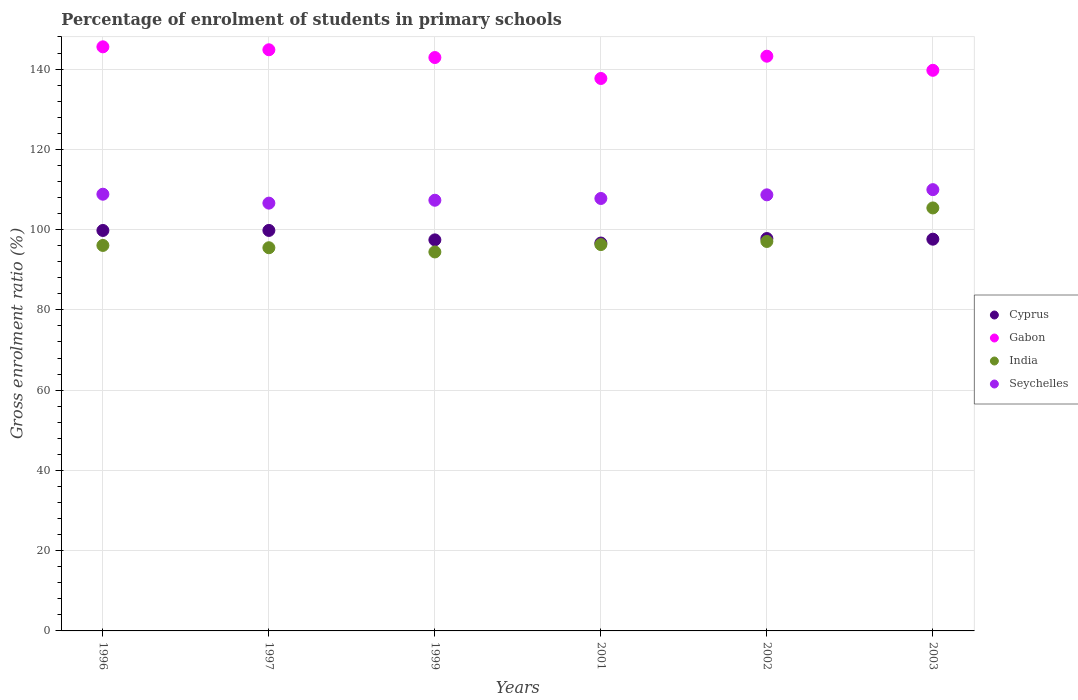What is the percentage of students enrolled in primary schools in India in 2003?
Your answer should be compact. 105.4. Across all years, what is the maximum percentage of students enrolled in primary schools in Seychelles?
Keep it short and to the point. 109.95. Across all years, what is the minimum percentage of students enrolled in primary schools in India?
Keep it short and to the point. 94.43. In which year was the percentage of students enrolled in primary schools in Cyprus maximum?
Keep it short and to the point. 1997. What is the total percentage of students enrolled in primary schools in India in the graph?
Make the answer very short. 584.67. What is the difference between the percentage of students enrolled in primary schools in Seychelles in 1996 and that in 2001?
Keep it short and to the point. 1.06. What is the difference between the percentage of students enrolled in primary schools in Gabon in 1997 and the percentage of students enrolled in primary schools in Cyprus in 1996?
Your answer should be very brief. 45.03. What is the average percentage of students enrolled in primary schools in Cyprus per year?
Provide a short and direct response. 98.17. In the year 2002, what is the difference between the percentage of students enrolled in primary schools in India and percentage of students enrolled in primary schools in Seychelles?
Offer a very short reply. -11.62. What is the ratio of the percentage of students enrolled in primary schools in Seychelles in 1999 to that in 2003?
Provide a succinct answer. 0.98. Is the percentage of students enrolled in primary schools in Seychelles in 1997 less than that in 1999?
Offer a very short reply. Yes. Is the difference between the percentage of students enrolled in primary schools in India in 2001 and 2003 greater than the difference between the percentage of students enrolled in primary schools in Seychelles in 2001 and 2003?
Give a very brief answer. No. What is the difference between the highest and the second highest percentage of students enrolled in primary schools in Seychelles?
Provide a short and direct response. 1.14. What is the difference between the highest and the lowest percentage of students enrolled in primary schools in India?
Your answer should be very brief. 10.97. In how many years, is the percentage of students enrolled in primary schools in Cyprus greater than the average percentage of students enrolled in primary schools in Cyprus taken over all years?
Provide a succinct answer. 2. Is it the case that in every year, the sum of the percentage of students enrolled in primary schools in Seychelles and percentage of students enrolled in primary schools in Gabon  is greater than the sum of percentage of students enrolled in primary schools in Cyprus and percentage of students enrolled in primary schools in India?
Provide a succinct answer. Yes. Is it the case that in every year, the sum of the percentage of students enrolled in primary schools in India and percentage of students enrolled in primary schools in Seychelles  is greater than the percentage of students enrolled in primary schools in Gabon?
Your answer should be compact. Yes. Is the percentage of students enrolled in primary schools in Gabon strictly greater than the percentage of students enrolled in primary schools in Seychelles over the years?
Your answer should be compact. Yes. Is the percentage of students enrolled in primary schools in Cyprus strictly less than the percentage of students enrolled in primary schools in India over the years?
Ensure brevity in your answer.  No. How many years are there in the graph?
Your answer should be compact. 6. What is the difference between two consecutive major ticks on the Y-axis?
Offer a terse response. 20. Are the values on the major ticks of Y-axis written in scientific E-notation?
Your answer should be compact. No. Does the graph contain grids?
Offer a terse response. Yes. Where does the legend appear in the graph?
Your answer should be compact. Center right. How many legend labels are there?
Keep it short and to the point. 4. What is the title of the graph?
Keep it short and to the point. Percentage of enrolment of students in primary schools. What is the Gross enrolment ratio (%) of Cyprus in 1996?
Provide a succinct answer. 99.78. What is the Gross enrolment ratio (%) in Gabon in 1996?
Provide a succinct answer. 145.54. What is the Gross enrolment ratio (%) in India in 1996?
Offer a terse response. 96.05. What is the Gross enrolment ratio (%) in Seychelles in 1996?
Give a very brief answer. 108.82. What is the Gross enrolment ratio (%) in Cyprus in 1997?
Make the answer very short. 99.79. What is the Gross enrolment ratio (%) of Gabon in 1997?
Your answer should be compact. 144.81. What is the Gross enrolment ratio (%) in India in 1997?
Keep it short and to the point. 95.48. What is the Gross enrolment ratio (%) in Seychelles in 1997?
Provide a short and direct response. 106.59. What is the Gross enrolment ratio (%) of Cyprus in 1999?
Give a very brief answer. 97.44. What is the Gross enrolment ratio (%) in Gabon in 1999?
Give a very brief answer. 142.87. What is the Gross enrolment ratio (%) in India in 1999?
Give a very brief answer. 94.43. What is the Gross enrolment ratio (%) in Seychelles in 1999?
Make the answer very short. 107.32. What is the Gross enrolment ratio (%) in Cyprus in 2001?
Your response must be concise. 96.65. What is the Gross enrolment ratio (%) of Gabon in 2001?
Your answer should be compact. 137.66. What is the Gross enrolment ratio (%) in India in 2001?
Make the answer very short. 96.27. What is the Gross enrolment ratio (%) of Seychelles in 2001?
Your answer should be compact. 107.76. What is the Gross enrolment ratio (%) in Cyprus in 2002?
Give a very brief answer. 97.77. What is the Gross enrolment ratio (%) of Gabon in 2002?
Provide a succinct answer. 143.21. What is the Gross enrolment ratio (%) in India in 2002?
Give a very brief answer. 97.04. What is the Gross enrolment ratio (%) in Seychelles in 2002?
Give a very brief answer. 108.66. What is the Gross enrolment ratio (%) in Cyprus in 2003?
Your answer should be very brief. 97.61. What is the Gross enrolment ratio (%) in Gabon in 2003?
Offer a very short reply. 139.69. What is the Gross enrolment ratio (%) in India in 2003?
Give a very brief answer. 105.4. What is the Gross enrolment ratio (%) of Seychelles in 2003?
Give a very brief answer. 109.95. Across all years, what is the maximum Gross enrolment ratio (%) in Cyprus?
Provide a succinct answer. 99.79. Across all years, what is the maximum Gross enrolment ratio (%) in Gabon?
Provide a succinct answer. 145.54. Across all years, what is the maximum Gross enrolment ratio (%) of India?
Offer a very short reply. 105.4. Across all years, what is the maximum Gross enrolment ratio (%) of Seychelles?
Ensure brevity in your answer.  109.95. Across all years, what is the minimum Gross enrolment ratio (%) in Cyprus?
Ensure brevity in your answer.  96.65. Across all years, what is the minimum Gross enrolment ratio (%) of Gabon?
Offer a terse response. 137.66. Across all years, what is the minimum Gross enrolment ratio (%) in India?
Give a very brief answer. 94.43. Across all years, what is the minimum Gross enrolment ratio (%) in Seychelles?
Offer a very short reply. 106.59. What is the total Gross enrolment ratio (%) in Cyprus in the graph?
Give a very brief answer. 589.05. What is the total Gross enrolment ratio (%) of Gabon in the graph?
Give a very brief answer. 853.78. What is the total Gross enrolment ratio (%) in India in the graph?
Offer a terse response. 584.67. What is the total Gross enrolment ratio (%) of Seychelles in the graph?
Make the answer very short. 649.1. What is the difference between the Gross enrolment ratio (%) in Cyprus in 1996 and that in 1997?
Keep it short and to the point. -0.01. What is the difference between the Gross enrolment ratio (%) of Gabon in 1996 and that in 1997?
Provide a short and direct response. 0.73. What is the difference between the Gross enrolment ratio (%) in India in 1996 and that in 1997?
Your answer should be very brief. 0.57. What is the difference between the Gross enrolment ratio (%) in Seychelles in 1996 and that in 1997?
Your answer should be compact. 2.22. What is the difference between the Gross enrolment ratio (%) of Cyprus in 1996 and that in 1999?
Your answer should be compact. 2.35. What is the difference between the Gross enrolment ratio (%) of Gabon in 1996 and that in 1999?
Your answer should be very brief. 2.67. What is the difference between the Gross enrolment ratio (%) in India in 1996 and that in 1999?
Provide a succinct answer. 1.62. What is the difference between the Gross enrolment ratio (%) in Seychelles in 1996 and that in 1999?
Provide a short and direct response. 1.5. What is the difference between the Gross enrolment ratio (%) of Cyprus in 1996 and that in 2001?
Offer a terse response. 3.13. What is the difference between the Gross enrolment ratio (%) of Gabon in 1996 and that in 2001?
Your answer should be very brief. 7.88. What is the difference between the Gross enrolment ratio (%) of India in 1996 and that in 2001?
Provide a short and direct response. -0.21. What is the difference between the Gross enrolment ratio (%) in Seychelles in 1996 and that in 2001?
Provide a short and direct response. 1.06. What is the difference between the Gross enrolment ratio (%) in Cyprus in 1996 and that in 2002?
Your response must be concise. 2.01. What is the difference between the Gross enrolment ratio (%) of Gabon in 1996 and that in 2002?
Your response must be concise. 2.34. What is the difference between the Gross enrolment ratio (%) of India in 1996 and that in 2002?
Keep it short and to the point. -0.99. What is the difference between the Gross enrolment ratio (%) of Seychelles in 1996 and that in 2002?
Offer a very short reply. 0.16. What is the difference between the Gross enrolment ratio (%) in Cyprus in 1996 and that in 2003?
Give a very brief answer. 2.17. What is the difference between the Gross enrolment ratio (%) of Gabon in 1996 and that in 2003?
Make the answer very short. 5.85. What is the difference between the Gross enrolment ratio (%) of India in 1996 and that in 2003?
Provide a short and direct response. -9.34. What is the difference between the Gross enrolment ratio (%) of Seychelles in 1996 and that in 2003?
Your response must be concise. -1.14. What is the difference between the Gross enrolment ratio (%) in Cyprus in 1997 and that in 1999?
Your answer should be very brief. 2.35. What is the difference between the Gross enrolment ratio (%) in Gabon in 1997 and that in 1999?
Offer a terse response. 1.93. What is the difference between the Gross enrolment ratio (%) of India in 1997 and that in 1999?
Give a very brief answer. 1.05. What is the difference between the Gross enrolment ratio (%) of Seychelles in 1997 and that in 1999?
Keep it short and to the point. -0.72. What is the difference between the Gross enrolment ratio (%) of Cyprus in 1997 and that in 2001?
Keep it short and to the point. 3.14. What is the difference between the Gross enrolment ratio (%) in Gabon in 1997 and that in 2001?
Your response must be concise. 7.15. What is the difference between the Gross enrolment ratio (%) of India in 1997 and that in 2001?
Provide a short and direct response. -0.79. What is the difference between the Gross enrolment ratio (%) in Seychelles in 1997 and that in 2001?
Provide a short and direct response. -1.16. What is the difference between the Gross enrolment ratio (%) of Cyprus in 1997 and that in 2002?
Your answer should be very brief. 2.02. What is the difference between the Gross enrolment ratio (%) of Gabon in 1997 and that in 2002?
Your answer should be compact. 1.6. What is the difference between the Gross enrolment ratio (%) of India in 1997 and that in 2002?
Make the answer very short. -1.56. What is the difference between the Gross enrolment ratio (%) in Seychelles in 1997 and that in 2002?
Your answer should be compact. -2.07. What is the difference between the Gross enrolment ratio (%) of Cyprus in 1997 and that in 2003?
Your answer should be compact. 2.18. What is the difference between the Gross enrolment ratio (%) of Gabon in 1997 and that in 2003?
Your response must be concise. 5.12. What is the difference between the Gross enrolment ratio (%) of India in 1997 and that in 2003?
Provide a short and direct response. -9.92. What is the difference between the Gross enrolment ratio (%) in Seychelles in 1997 and that in 2003?
Make the answer very short. -3.36. What is the difference between the Gross enrolment ratio (%) in Cyprus in 1999 and that in 2001?
Your answer should be compact. 0.79. What is the difference between the Gross enrolment ratio (%) of Gabon in 1999 and that in 2001?
Your answer should be compact. 5.22. What is the difference between the Gross enrolment ratio (%) in India in 1999 and that in 2001?
Provide a succinct answer. -1.84. What is the difference between the Gross enrolment ratio (%) of Seychelles in 1999 and that in 2001?
Provide a short and direct response. -0.44. What is the difference between the Gross enrolment ratio (%) of Cyprus in 1999 and that in 2002?
Your response must be concise. -0.34. What is the difference between the Gross enrolment ratio (%) in Gabon in 1999 and that in 2002?
Give a very brief answer. -0.33. What is the difference between the Gross enrolment ratio (%) of India in 1999 and that in 2002?
Provide a succinct answer. -2.61. What is the difference between the Gross enrolment ratio (%) in Seychelles in 1999 and that in 2002?
Keep it short and to the point. -1.34. What is the difference between the Gross enrolment ratio (%) of Cyprus in 1999 and that in 2003?
Give a very brief answer. -0.17. What is the difference between the Gross enrolment ratio (%) of Gabon in 1999 and that in 2003?
Your answer should be very brief. 3.18. What is the difference between the Gross enrolment ratio (%) of India in 1999 and that in 2003?
Provide a succinct answer. -10.97. What is the difference between the Gross enrolment ratio (%) of Seychelles in 1999 and that in 2003?
Your response must be concise. -2.64. What is the difference between the Gross enrolment ratio (%) of Cyprus in 2001 and that in 2002?
Your response must be concise. -1.12. What is the difference between the Gross enrolment ratio (%) in Gabon in 2001 and that in 2002?
Your answer should be compact. -5.55. What is the difference between the Gross enrolment ratio (%) of India in 2001 and that in 2002?
Make the answer very short. -0.78. What is the difference between the Gross enrolment ratio (%) of Seychelles in 2001 and that in 2002?
Provide a succinct answer. -0.91. What is the difference between the Gross enrolment ratio (%) in Cyprus in 2001 and that in 2003?
Your answer should be compact. -0.96. What is the difference between the Gross enrolment ratio (%) of Gabon in 2001 and that in 2003?
Give a very brief answer. -2.04. What is the difference between the Gross enrolment ratio (%) in India in 2001 and that in 2003?
Ensure brevity in your answer.  -9.13. What is the difference between the Gross enrolment ratio (%) in Seychelles in 2001 and that in 2003?
Your response must be concise. -2.2. What is the difference between the Gross enrolment ratio (%) of Cyprus in 2002 and that in 2003?
Make the answer very short. 0.16. What is the difference between the Gross enrolment ratio (%) in Gabon in 2002 and that in 2003?
Your response must be concise. 3.51. What is the difference between the Gross enrolment ratio (%) in India in 2002 and that in 2003?
Make the answer very short. -8.35. What is the difference between the Gross enrolment ratio (%) in Seychelles in 2002 and that in 2003?
Your response must be concise. -1.29. What is the difference between the Gross enrolment ratio (%) of Cyprus in 1996 and the Gross enrolment ratio (%) of Gabon in 1997?
Ensure brevity in your answer.  -45.03. What is the difference between the Gross enrolment ratio (%) of Cyprus in 1996 and the Gross enrolment ratio (%) of India in 1997?
Provide a short and direct response. 4.3. What is the difference between the Gross enrolment ratio (%) of Cyprus in 1996 and the Gross enrolment ratio (%) of Seychelles in 1997?
Ensure brevity in your answer.  -6.81. What is the difference between the Gross enrolment ratio (%) of Gabon in 1996 and the Gross enrolment ratio (%) of India in 1997?
Ensure brevity in your answer.  50.06. What is the difference between the Gross enrolment ratio (%) of Gabon in 1996 and the Gross enrolment ratio (%) of Seychelles in 1997?
Provide a succinct answer. 38.95. What is the difference between the Gross enrolment ratio (%) of India in 1996 and the Gross enrolment ratio (%) of Seychelles in 1997?
Your answer should be very brief. -10.54. What is the difference between the Gross enrolment ratio (%) in Cyprus in 1996 and the Gross enrolment ratio (%) in Gabon in 1999?
Ensure brevity in your answer.  -43.09. What is the difference between the Gross enrolment ratio (%) of Cyprus in 1996 and the Gross enrolment ratio (%) of India in 1999?
Ensure brevity in your answer.  5.35. What is the difference between the Gross enrolment ratio (%) in Cyprus in 1996 and the Gross enrolment ratio (%) in Seychelles in 1999?
Offer a very short reply. -7.53. What is the difference between the Gross enrolment ratio (%) of Gabon in 1996 and the Gross enrolment ratio (%) of India in 1999?
Provide a short and direct response. 51.11. What is the difference between the Gross enrolment ratio (%) in Gabon in 1996 and the Gross enrolment ratio (%) in Seychelles in 1999?
Ensure brevity in your answer.  38.23. What is the difference between the Gross enrolment ratio (%) of India in 1996 and the Gross enrolment ratio (%) of Seychelles in 1999?
Provide a succinct answer. -11.26. What is the difference between the Gross enrolment ratio (%) in Cyprus in 1996 and the Gross enrolment ratio (%) in Gabon in 2001?
Make the answer very short. -37.87. What is the difference between the Gross enrolment ratio (%) of Cyprus in 1996 and the Gross enrolment ratio (%) of India in 2001?
Provide a succinct answer. 3.52. What is the difference between the Gross enrolment ratio (%) in Cyprus in 1996 and the Gross enrolment ratio (%) in Seychelles in 2001?
Provide a succinct answer. -7.97. What is the difference between the Gross enrolment ratio (%) in Gabon in 1996 and the Gross enrolment ratio (%) in India in 2001?
Provide a succinct answer. 49.27. What is the difference between the Gross enrolment ratio (%) of Gabon in 1996 and the Gross enrolment ratio (%) of Seychelles in 2001?
Your answer should be very brief. 37.79. What is the difference between the Gross enrolment ratio (%) in India in 1996 and the Gross enrolment ratio (%) in Seychelles in 2001?
Offer a terse response. -11.7. What is the difference between the Gross enrolment ratio (%) in Cyprus in 1996 and the Gross enrolment ratio (%) in Gabon in 2002?
Offer a very short reply. -43.42. What is the difference between the Gross enrolment ratio (%) of Cyprus in 1996 and the Gross enrolment ratio (%) of India in 2002?
Offer a very short reply. 2.74. What is the difference between the Gross enrolment ratio (%) of Cyprus in 1996 and the Gross enrolment ratio (%) of Seychelles in 2002?
Offer a very short reply. -8.88. What is the difference between the Gross enrolment ratio (%) in Gabon in 1996 and the Gross enrolment ratio (%) in India in 2002?
Your answer should be compact. 48.5. What is the difference between the Gross enrolment ratio (%) in Gabon in 1996 and the Gross enrolment ratio (%) in Seychelles in 2002?
Keep it short and to the point. 36.88. What is the difference between the Gross enrolment ratio (%) of India in 1996 and the Gross enrolment ratio (%) of Seychelles in 2002?
Your answer should be very brief. -12.61. What is the difference between the Gross enrolment ratio (%) in Cyprus in 1996 and the Gross enrolment ratio (%) in Gabon in 2003?
Give a very brief answer. -39.91. What is the difference between the Gross enrolment ratio (%) in Cyprus in 1996 and the Gross enrolment ratio (%) in India in 2003?
Offer a terse response. -5.61. What is the difference between the Gross enrolment ratio (%) of Cyprus in 1996 and the Gross enrolment ratio (%) of Seychelles in 2003?
Your response must be concise. -10.17. What is the difference between the Gross enrolment ratio (%) of Gabon in 1996 and the Gross enrolment ratio (%) of India in 2003?
Your answer should be very brief. 40.14. What is the difference between the Gross enrolment ratio (%) in Gabon in 1996 and the Gross enrolment ratio (%) in Seychelles in 2003?
Your answer should be very brief. 35.59. What is the difference between the Gross enrolment ratio (%) in India in 1996 and the Gross enrolment ratio (%) in Seychelles in 2003?
Offer a terse response. -13.9. What is the difference between the Gross enrolment ratio (%) in Cyprus in 1997 and the Gross enrolment ratio (%) in Gabon in 1999?
Offer a very short reply. -43.08. What is the difference between the Gross enrolment ratio (%) in Cyprus in 1997 and the Gross enrolment ratio (%) in India in 1999?
Provide a succinct answer. 5.36. What is the difference between the Gross enrolment ratio (%) of Cyprus in 1997 and the Gross enrolment ratio (%) of Seychelles in 1999?
Provide a succinct answer. -7.52. What is the difference between the Gross enrolment ratio (%) of Gabon in 1997 and the Gross enrolment ratio (%) of India in 1999?
Offer a very short reply. 50.38. What is the difference between the Gross enrolment ratio (%) of Gabon in 1997 and the Gross enrolment ratio (%) of Seychelles in 1999?
Keep it short and to the point. 37.49. What is the difference between the Gross enrolment ratio (%) of India in 1997 and the Gross enrolment ratio (%) of Seychelles in 1999?
Offer a very short reply. -11.84. What is the difference between the Gross enrolment ratio (%) of Cyprus in 1997 and the Gross enrolment ratio (%) of Gabon in 2001?
Offer a terse response. -37.86. What is the difference between the Gross enrolment ratio (%) in Cyprus in 1997 and the Gross enrolment ratio (%) in India in 2001?
Make the answer very short. 3.53. What is the difference between the Gross enrolment ratio (%) of Cyprus in 1997 and the Gross enrolment ratio (%) of Seychelles in 2001?
Provide a succinct answer. -7.96. What is the difference between the Gross enrolment ratio (%) in Gabon in 1997 and the Gross enrolment ratio (%) in India in 2001?
Provide a succinct answer. 48.54. What is the difference between the Gross enrolment ratio (%) in Gabon in 1997 and the Gross enrolment ratio (%) in Seychelles in 2001?
Ensure brevity in your answer.  37.05. What is the difference between the Gross enrolment ratio (%) in India in 1997 and the Gross enrolment ratio (%) in Seychelles in 2001?
Offer a terse response. -12.28. What is the difference between the Gross enrolment ratio (%) of Cyprus in 1997 and the Gross enrolment ratio (%) of Gabon in 2002?
Keep it short and to the point. -43.41. What is the difference between the Gross enrolment ratio (%) in Cyprus in 1997 and the Gross enrolment ratio (%) in India in 2002?
Ensure brevity in your answer.  2.75. What is the difference between the Gross enrolment ratio (%) in Cyprus in 1997 and the Gross enrolment ratio (%) in Seychelles in 2002?
Provide a short and direct response. -8.87. What is the difference between the Gross enrolment ratio (%) in Gabon in 1997 and the Gross enrolment ratio (%) in India in 2002?
Provide a succinct answer. 47.77. What is the difference between the Gross enrolment ratio (%) in Gabon in 1997 and the Gross enrolment ratio (%) in Seychelles in 2002?
Your response must be concise. 36.15. What is the difference between the Gross enrolment ratio (%) in India in 1997 and the Gross enrolment ratio (%) in Seychelles in 2002?
Make the answer very short. -13.18. What is the difference between the Gross enrolment ratio (%) in Cyprus in 1997 and the Gross enrolment ratio (%) in Gabon in 2003?
Provide a succinct answer. -39.9. What is the difference between the Gross enrolment ratio (%) in Cyprus in 1997 and the Gross enrolment ratio (%) in India in 2003?
Make the answer very short. -5.6. What is the difference between the Gross enrolment ratio (%) of Cyprus in 1997 and the Gross enrolment ratio (%) of Seychelles in 2003?
Provide a short and direct response. -10.16. What is the difference between the Gross enrolment ratio (%) of Gabon in 1997 and the Gross enrolment ratio (%) of India in 2003?
Your answer should be very brief. 39.41. What is the difference between the Gross enrolment ratio (%) in Gabon in 1997 and the Gross enrolment ratio (%) in Seychelles in 2003?
Your answer should be very brief. 34.85. What is the difference between the Gross enrolment ratio (%) of India in 1997 and the Gross enrolment ratio (%) of Seychelles in 2003?
Offer a very short reply. -14.48. What is the difference between the Gross enrolment ratio (%) in Cyprus in 1999 and the Gross enrolment ratio (%) in Gabon in 2001?
Give a very brief answer. -40.22. What is the difference between the Gross enrolment ratio (%) of Cyprus in 1999 and the Gross enrolment ratio (%) of India in 2001?
Give a very brief answer. 1.17. What is the difference between the Gross enrolment ratio (%) in Cyprus in 1999 and the Gross enrolment ratio (%) in Seychelles in 2001?
Give a very brief answer. -10.32. What is the difference between the Gross enrolment ratio (%) in Gabon in 1999 and the Gross enrolment ratio (%) in India in 2001?
Offer a very short reply. 46.61. What is the difference between the Gross enrolment ratio (%) in Gabon in 1999 and the Gross enrolment ratio (%) in Seychelles in 2001?
Provide a short and direct response. 35.12. What is the difference between the Gross enrolment ratio (%) of India in 1999 and the Gross enrolment ratio (%) of Seychelles in 2001?
Ensure brevity in your answer.  -13.32. What is the difference between the Gross enrolment ratio (%) in Cyprus in 1999 and the Gross enrolment ratio (%) in Gabon in 2002?
Keep it short and to the point. -45.77. What is the difference between the Gross enrolment ratio (%) of Cyprus in 1999 and the Gross enrolment ratio (%) of India in 2002?
Your answer should be compact. 0.4. What is the difference between the Gross enrolment ratio (%) in Cyprus in 1999 and the Gross enrolment ratio (%) in Seychelles in 2002?
Offer a terse response. -11.22. What is the difference between the Gross enrolment ratio (%) of Gabon in 1999 and the Gross enrolment ratio (%) of India in 2002?
Give a very brief answer. 45.83. What is the difference between the Gross enrolment ratio (%) in Gabon in 1999 and the Gross enrolment ratio (%) in Seychelles in 2002?
Provide a short and direct response. 34.21. What is the difference between the Gross enrolment ratio (%) in India in 1999 and the Gross enrolment ratio (%) in Seychelles in 2002?
Your answer should be compact. -14.23. What is the difference between the Gross enrolment ratio (%) of Cyprus in 1999 and the Gross enrolment ratio (%) of Gabon in 2003?
Your answer should be compact. -42.25. What is the difference between the Gross enrolment ratio (%) of Cyprus in 1999 and the Gross enrolment ratio (%) of India in 2003?
Give a very brief answer. -7.96. What is the difference between the Gross enrolment ratio (%) of Cyprus in 1999 and the Gross enrolment ratio (%) of Seychelles in 2003?
Your answer should be compact. -12.52. What is the difference between the Gross enrolment ratio (%) in Gabon in 1999 and the Gross enrolment ratio (%) in India in 2003?
Offer a very short reply. 37.48. What is the difference between the Gross enrolment ratio (%) of Gabon in 1999 and the Gross enrolment ratio (%) of Seychelles in 2003?
Give a very brief answer. 32.92. What is the difference between the Gross enrolment ratio (%) in India in 1999 and the Gross enrolment ratio (%) in Seychelles in 2003?
Your answer should be very brief. -15.52. What is the difference between the Gross enrolment ratio (%) in Cyprus in 2001 and the Gross enrolment ratio (%) in Gabon in 2002?
Make the answer very short. -46.56. What is the difference between the Gross enrolment ratio (%) of Cyprus in 2001 and the Gross enrolment ratio (%) of India in 2002?
Give a very brief answer. -0.39. What is the difference between the Gross enrolment ratio (%) of Cyprus in 2001 and the Gross enrolment ratio (%) of Seychelles in 2002?
Provide a succinct answer. -12.01. What is the difference between the Gross enrolment ratio (%) in Gabon in 2001 and the Gross enrolment ratio (%) in India in 2002?
Your answer should be compact. 40.61. What is the difference between the Gross enrolment ratio (%) in Gabon in 2001 and the Gross enrolment ratio (%) in Seychelles in 2002?
Your response must be concise. 29. What is the difference between the Gross enrolment ratio (%) in India in 2001 and the Gross enrolment ratio (%) in Seychelles in 2002?
Offer a terse response. -12.39. What is the difference between the Gross enrolment ratio (%) of Cyprus in 2001 and the Gross enrolment ratio (%) of Gabon in 2003?
Offer a very short reply. -43.04. What is the difference between the Gross enrolment ratio (%) of Cyprus in 2001 and the Gross enrolment ratio (%) of India in 2003?
Make the answer very short. -8.75. What is the difference between the Gross enrolment ratio (%) in Cyprus in 2001 and the Gross enrolment ratio (%) in Seychelles in 2003?
Offer a very short reply. -13.31. What is the difference between the Gross enrolment ratio (%) in Gabon in 2001 and the Gross enrolment ratio (%) in India in 2003?
Provide a succinct answer. 32.26. What is the difference between the Gross enrolment ratio (%) of Gabon in 2001 and the Gross enrolment ratio (%) of Seychelles in 2003?
Ensure brevity in your answer.  27.7. What is the difference between the Gross enrolment ratio (%) in India in 2001 and the Gross enrolment ratio (%) in Seychelles in 2003?
Your answer should be very brief. -13.69. What is the difference between the Gross enrolment ratio (%) in Cyprus in 2002 and the Gross enrolment ratio (%) in Gabon in 2003?
Your answer should be compact. -41.92. What is the difference between the Gross enrolment ratio (%) in Cyprus in 2002 and the Gross enrolment ratio (%) in India in 2003?
Ensure brevity in your answer.  -7.62. What is the difference between the Gross enrolment ratio (%) of Cyprus in 2002 and the Gross enrolment ratio (%) of Seychelles in 2003?
Offer a very short reply. -12.18. What is the difference between the Gross enrolment ratio (%) in Gabon in 2002 and the Gross enrolment ratio (%) in India in 2003?
Your response must be concise. 37.81. What is the difference between the Gross enrolment ratio (%) of Gabon in 2002 and the Gross enrolment ratio (%) of Seychelles in 2003?
Your response must be concise. 33.25. What is the difference between the Gross enrolment ratio (%) of India in 2002 and the Gross enrolment ratio (%) of Seychelles in 2003?
Your response must be concise. -12.91. What is the average Gross enrolment ratio (%) of Cyprus per year?
Provide a succinct answer. 98.17. What is the average Gross enrolment ratio (%) in Gabon per year?
Provide a succinct answer. 142.3. What is the average Gross enrolment ratio (%) of India per year?
Give a very brief answer. 97.44. What is the average Gross enrolment ratio (%) of Seychelles per year?
Make the answer very short. 108.18. In the year 1996, what is the difference between the Gross enrolment ratio (%) in Cyprus and Gross enrolment ratio (%) in Gabon?
Provide a short and direct response. -45.76. In the year 1996, what is the difference between the Gross enrolment ratio (%) in Cyprus and Gross enrolment ratio (%) in India?
Provide a succinct answer. 3.73. In the year 1996, what is the difference between the Gross enrolment ratio (%) of Cyprus and Gross enrolment ratio (%) of Seychelles?
Keep it short and to the point. -9.03. In the year 1996, what is the difference between the Gross enrolment ratio (%) in Gabon and Gross enrolment ratio (%) in India?
Your response must be concise. 49.49. In the year 1996, what is the difference between the Gross enrolment ratio (%) in Gabon and Gross enrolment ratio (%) in Seychelles?
Give a very brief answer. 36.72. In the year 1996, what is the difference between the Gross enrolment ratio (%) of India and Gross enrolment ratio (%) of Seychelles?
Ensure brevity in your answer.  -12.76. In the year 1997, what is the difference between the Gross enrolment ratio (%) of Cyprus and Gross enrolment ratio (%) of Gabon?
Offer a terse response. -45.02. In the year 1997, what is the difference between the Gross enrolment ratio (%) of Cyprus and Gross enrolment ratio (%) of India?
Your answer should be compact. 4.31. In the year 1997, what is the difference between the Gross enrolment ratio (%) of Cyprus and Gross enrolment ratio (%) of Seychelles?
Ensure brevity in your answer.  -6.8. In the year 1997, what is the difference between the Gross enrolment ratio (%) of Gabon and Gross enrolment ratio (%) of India?
Keep it short and to the point. 49.33. In the year 1997, what is the difference between the Gross enrolment ratio (%) of Gabon and Gross enrolment ratio (%) of Seychelles?
Your answer should be compact. 38.22. In the year 1997, what is the difference between the Gross enrolment ratio (%) in India and Gross enrolment ratio (%) in Seychelles?
Offer a terse response. -11.12. In the year 1999, what is the difference between the Gross enrolment ratio (%) in Cyprus and Gross enrolment ratio (%) in Gabon?
Your answer should be very brief. -45.44. In the year 1999, what is the difference between the Gross enrolment ratio (%) in Cyprus and Gross enrolment ratio (%) in India?
Keep it short and to the point. 3.01. In the year 1999, what is the difference between the Gross enrolment ratio (%) of Cyprus and Gross enrolment ratio (%) of Seychelles?
Provide a succinct answer. -9.88. In the year 1999, what is the difference between the Gross enrolment ratio (%) of Gabon and Gross enrolment ratio (%) of India?
Give a very brief answer. 48.44. In the year 1999, what is the difference between the Gross enrolment ratio (%) in Gabon and Gross enrolment ratio (%) in Seychelles?
Offer a very short reply. 35.56. In the year 1999, what is the difference between the Gross enrolment ratio (%) in India and Gross enrolment ratio (%) in Seychelles?
Offer a very short reply. -12.89. In the year 2001, what is the difference between the Gross enrolment ratio (%) of Cyprus and Gross enrolment ratio (%) of Gabon?
Provide a short and direct response. -41.01. In the year 2001, what is the difference between the Gross enrolment ratio (%) in Cyprus and Gross enrolment ratio (%) in India?
Your answer should be compact. 0.38. In the year 2001, what is the difference between the Gross enrolment ratio (%) of Cyprus and Gross enrolment ratio (%) of Seychelles?
Give a very brief answer. -11.11. In the year 2001, what is the difference between the Gross enrolment ratio (%) in Gabon and Gross enrolment ratio (%) in India?
Keep it short and to the point. 41.39. In the year 2001, what is the difference between the Gross enrolment ratio (%) of Gabon and Gross enrolment ratio (%) of Seychelles?
Offer a very short reply. 29.9. In the year 2001, what is the difference between the Gross enrolment ratio (%) in India and Gross enrolment ratio (%) in Seychelles?
Your answer should be very brief. -11.49. In the year 2002, what is the difference between the Gross enrolment ratio (%) of Cyprus and Gross enrolment ratio (%) of Gabon?
Your answer should be compact. -45.43. In the year 2002, what is the difference between the Gross enrolment ratio (%) of Cyprus and Gross enrolment ratio (%) of India?
Keep it short and to the point. 0.73. In the year 2002, what is the difference between the Gross enrolment ratio (%) in Cyprus and Gross enrolment ratio (%) in Seychelles?
Keep it short and to the point. -10.89. In the year 2002, what is the difference between the Gross enrolment ratio (%) in Gabon and Gross enrolment ratio (%) in India?
Ensure brevity in your answer.  46.16. In the year 2002, what is the difference between the Gross enrolment ratio (%) of Gabon and Gross enrolment ratio (%) of Seychelles?
Ensure brevity in your answer.  34.54. In the year 2002, what is the difference between the Gross enrolment ratio (%) of India and Gross enrolment ratio (%) of Seychelles?
Your answer should be very brief. -11.62. In the year 2003, what is the difference between the Gross enrolment ratio (%) in Cyprus and Gross enrolment ratio (%) in Gabon?
Keep it short and to the point. -42.08. In the year 2003, what is the difference between the Gross enrolment ratio (%) of Cyprus and Gross enrolment ratio (%) of India?
Keep it short and to the point. -7.79. In the year 2003, what is the difference between the Gross enrolment ratio (%) in Cyprus and Gross enrolment ratio (%) in Seychelles?
Your answer should be very brief. -12.34. In the year 2003, what is the difference between the Gross enrolment ratio (%) of Gabon and Gross enrolment ratio (%) of India?
Make the answer very short. 34.3. In the year 2003, what is the difference between the Gross enrolment ratio (%) in Gabon and Gross enrolment ratio (%) in Seychelles?
Provide a short and direct response. 29.74. In the year 2003, what is the difference between the Gross enrolment ratio (%) in India and Gross enrolment ratio (%) in Seychelles?
Your answer should be compact. -4.56. What is the ratio of the Gross enrolment ratio (%) in Cyprus in 1996 to that in 1997?
Your answer should be very brief. 1. What is the ratio of the Gross enrolment ratio (%) in India in 1996 to that in 1997?
Provide a succinct answer. 1.01. What is the ratio of the Gross enrolment ratio (%) of Seychelles in 1996 to that in 1997?
Make the answer very short. 1.02. What is the ratio of the Gross enrolment ratio (%) in Cyprus in 1996 to that in 1999?
Keep it short and to the point. 1.02. What is the ratio of the Gross enrolment ratio (%) of Gabon in 1996 to that in 1999?
Offer a terse response. 1.02. What is the ratio of the Gross enrolment ratio (%) in India in 1996 to that in 1999?
Provide a short and direct response. 1.02. What is the ratio of the Gross enrolment ratio (%) in Cyprus in 1996 to that in 2001?
Provide a succinct answer. 1.03. What is the ratio of the Gross enrolment ratio (%) of Gabon in 1996 to that in 2001?
Give a very brief answer. 1.06. What is the ratio of the Gross enrolment ratio (%) in India in 1996 to that in 2001?
Give a very brief answer. 1. What is the ratio of the Gross enrolment ratio (%) of Seychelles in 1996 to that in 2001?
Offer a terse response. 1.01. What is the ratio of the Gross enrolment ratio (%) in Cyprus in 1996 to that in 2002?
Your answer should be compact. 1.02. What is the ratio of the Gross enrolment ratio (%) of Gabon in 1996 to that in 2002?
Keep it short and to the point. 1.02. What is the ratio of the Gross enrolment ratio (%) of Cyprus in 1996 to that in 2003?
Offer a very short reply. 1.02. What is the ratio of the Gross enrolment ratio (%) of Gabon in 1996 to that in 2003?
Your answer should be compact. 1.04. What is the ratio of the Gross enrolment ratio (%) in India in 1996 to that in 2003?
Provide a short and direct response. 0.91. What is the ratio of the Gross enrolment ratio (%) in Cyprus in 1997 to that in 1999?
Your answer should be compact. 1.02. What is the ratio of the Gross enrolment ratio (%) of Gabon in 1997 to that in 1999?
Your answer should be very brief. 1.01. What is the ratio of the Gross enrolment ratio (%) of India in 1997 to that in 1999?
Your response must be concise. 1.01. What is the ratio of the Gross enrolment ratio (%) in Seychelles in 1997 to that in 1999?
Your response must be concise. 0.99. What is the ratio of the Gross enrolment ratio (%) of Cyprus in 1997 to that in 2001?
Offer a terse response. 1.03. What is the ratio of the Gross enrolment ratio (%) in Gabon in 1997 to that in 2001?
Provide a short and direct response. 1.05. What is the ratio of the Gross enrolment ratio (%) in India in 1997 to that in 2001?
Offer a very short reply. 0.99. What is the ratio of the Gross enrolment ratio (%) in Cyprus in 1997 to that in 2002?
Provide a succinct answer. 1.02. What is the ratio of the Gross enrolment ratio (%) of Gabon in 1997 to that in 2002?
Your answer should be very brief. 1.01. What is the ratio of the Gross enrolment ratio (%) of India in 1997 to that in 2002?
Offer a terse response. 0.98. What is the ratio of the Gross enrolment ratio (%) of Seychelles in 1997 to that in 2002?
Keep it short and to the point. 0.98. What is the ratio of the Gross enrolment ratio (%) of Cyprus in 1997 to that in 2003?
Offer a terse response. 1.02. What is the ratio of the Gross enrolment ratio (%) in Gabon in 1997 to that in 2003?
Offer a terse response. 1.04. What is the ratio of the Gross enrolment ratio (%) of India in 1997 to that in 2003?
Provide a succinct answer. 0.91. What is the ratio of the Gross enrolment ratio (%) in Seychelles in 1997 to that in 2003?
Keep it short and to the point. 0.97. What is the ratio of the Gross enrolment ratio (%) of Cyprus in 1999 to that in 2001?
Offer a terse response. 1.01. What is the ratio of the Gross enrolment ratio (%) of Gabon in 1999 to that in 2001?
Your response must be concise. 1.04. What is the ratio of the Gross enrolment ratio (%) of India in 1999 to that in 2001?
Your response must be concise. 0.98. What is the ratio of the Gross enrolment ratio (%) in Cyprus in 1999 to that in 2002?
Provide a succinct answer. 1. What is the ratio of the Gross enrolment ratio (%) in Gabon in 1999 to that in 2002?
Your answer should be very brief. 1. What is the ratio of the Gross enrolment ratio (%) of India in 1999 to that in 2002?
Give a very brief answer. 0.97. What is the ratio of the Gross enrolment ratio (%) of Seychelles in 1999 to that in 2002?
Your response must be concise. 0.99. What is the ratio of the Gross enrolment ratio (%) in Gabon in 1999 to that in 2003?
Make the answer very short. 1.02. What is the ratio of the Gross enrolment ratio (%) of India in 1999 to that in 2003?
Provide a succinct answer. 0.9. What is the ratio of the Gross enrolment ratio (%) in Seychelles in 1999 to that in 2003?
Make the answer very short. 0.98. What is the ratio of the Gross enrolment ratio (%) in Cyprus in 2001 to that in 2002?
Your response must be concise. 0.99. What is the ratio of the Gross enrolment ratio (%) in Gabon in 2001 to that in 2002?
Offer a very short reply. 0.96. What is the ratio of the Gross enrolment ratio (%) in India in 2001 to that in 2002?
Provide a succinct answer. 0.99. What is the ratio of the Gross enrolment ratio (%) of Seychelles in 2001 to that in 2002?
Ensure brevity in your answer.  0.99. What is the ratio of the Gross enrolment ratio (%) of Cyprus in 2001 to that in 2003?
Offer a terse response. 0.99. What is the ratio of the Gross enrolment ratio (%) in Gabon in 2001 to that in 2003?
Your answer should be compact. 0.99. What is the ratio of the Gross enrolment ratio (%) of India in 2001 to that in 2003?
Your answer should be very brief. 0.91. What is the ratio of the Gross enrolment ratio (%) of Seychelles in 2001 to that in 2003?
Offer a very short reply. 0.98. What is the ratio of the Gross enrolment ratio (%) of Gabon in 2002 to that in 2003?
Offer a very short reply. 1.03. What is the ratio of the Gross enrolment ratio (%) in India in 2002 to that in 2003?
Offer a terse response. 0.92. What is the difference between the highest and the second highest Gross enrolment ratio (%) of Cyprus?
Your answer should be very brief. 0.01. What is the difference between the highest and the second highest Gross enrolment ratio (%) in Gabon?
Keep it short and to the point. 0.73. What is the difference between the highest and the second highest Gross enrolment ratio (%) of India?
Your answer should be compact. 8.35. What is the difference between the highest and the second highest Gross enrolment ratio (%) of Seychelles?
Make the answer very short. 1.14. What is the difference between the highest and the lowest Gross enrolment ratio (%) of Cyprus?
Make the answer very short. 3.14. What is the difference between the highest and the lowest Gross enrolment ratio (%) in Gabon?
Offer a very short reply. 7.88. What is the difference between the highest and the lowest Gross enrolment ratio (%) of India?
Provide a succinct answer. 10.97. What is the difference between the highest and the lowest Gross enrolment ratio (%) in Seychelles?
Your answer should be compact. 3.36. 